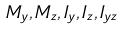Convert formula to latex. <formula><loc_0><loc_0><loc_500><loc_500>M _ { y } , M _ { z } , I _ { y } , I _ { z } , I _ { y z }</formula> 